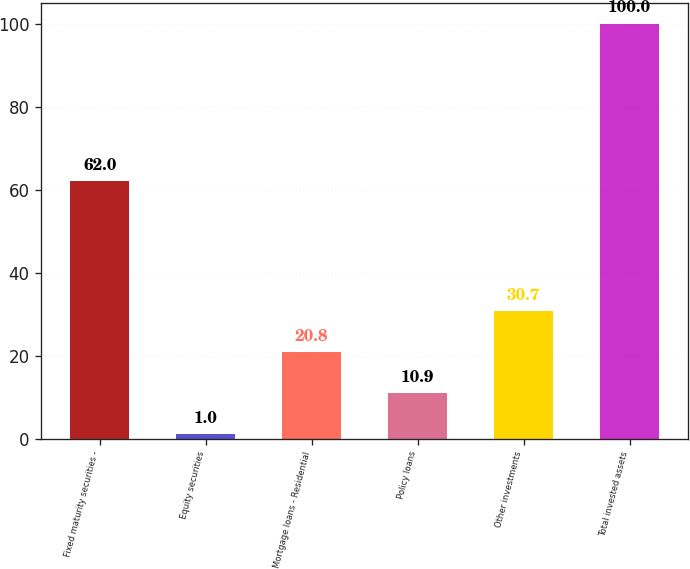Convert chart. <chart><loc_0><loc_0><loc_500><loc_500><bar_chart><fcel>Fixed maturity securities -<fcel>Equity securities<fcel>Mortgage loans - Residential<fcel>Policy loans<fcel>Other investments<fcel>Total invested assets<nl><fcel>62<fcel>1<fcel>20.8<fcel>10.9<fcel>30.7<fcel>100<nl></chart> 